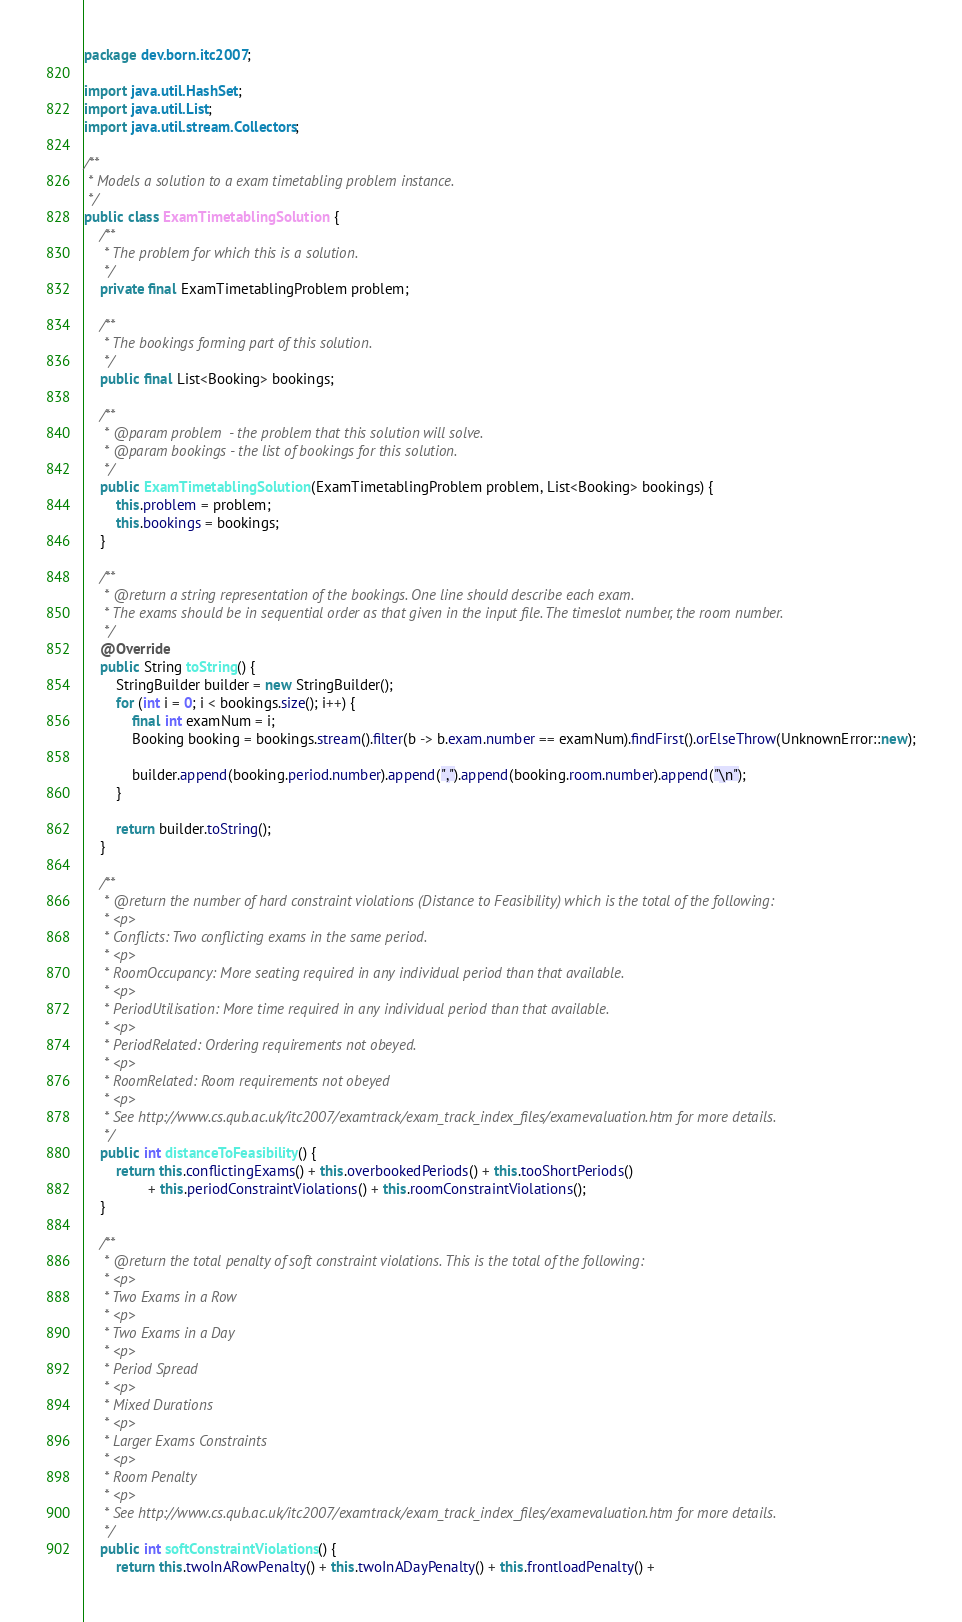<code> <loc_0><loc_0><loc_500><loc_500><_Java_>package dev.born.itc2007;

import java.util.HashSet;
import java.util.List;
import java.util.stream.Collectors;

/**
 * Models a solution to a exam timetabling problem instance.
 */
public class ExamTimetablingSolution {
	/**
	 * The problem for which this is a solution.
	 */
	private final ExamTimetablingProblem problem;

	/**
	 * The bookings forming part of this solution.
	 */
	public final List<Booking> bookings;

	/**
	 * @param problem  - the problem that this solution will solve.
	 * @param bookings - the list of bookings for this solution.
	 */
	public ExamTimetablingSolution(ExamTimetablingProblem problem, List<Booking> bookings) {
		this.problem = problem;
		this.bookings = bookings;
	}

	/**
	 * @return a string representation of the bookings. One line should describe each exam.
	 * The exams should be in sequential order as that given in the input file. The timeslot number, the room number.
	 */
	@Override
	public String toString() {
		StringBuilder builder = new StringBuilder();
		for (int i = 0; i < bookings.size(); i++) {
			final int examNum = i;
			Booking booking = bookings.stream().filter(b -> b.exam.number == examNum).findFirst().orElseThrow(UnknownError::new);

			builder.append(booking.period.number).append(",").append(booking.room.number).append("\n");
		}

		return builder.toString();
	}

	/**
	 * @return the number of hard constraint violations (Distance to Feasibility) which is the total of the following:
	 * <p>
	 * Conflicts: Two conflicting exams in the same period.
	 * <p>
	 * RoomOccupancy: More seating required in any individual period than that available.
	 * <p>
	 * PeriodUtilisation: More time required in any individual period than that available.
	 * <p>
	 * PeriodRelated: Ordering requirements not obeyed.
	 * <p>
	 * RoomRelated: Room requirements not obeyed
	 * <p>
	 * See http://www.cs.qub.ac.uk/itc2007/examtrack/exam_track_index_files/examevaluation.htm for more details.
	 */
	public int distanceToFeasibility() {
		return this.conflictingExams() + this.overbookedPeriods() + this.tooShortPeriods()
				+ this.periodConstraintViolations() + this.roomConstraintViolations();
	}

	/**
	 * @return the total penalty of soft constraint violations. This is the total of the following:
	 * <p>
	 * Two Exams in a Row
	 * <p>
	 * Two Exams in a Day
	 * <p>
	 * Period Spread
	 * <p>
	 * Mixed Durations
	 * <p>
	 * Larger Exams Constraints
	 * <p>
	 * Room Penalty
	 * <p>
	 * See http://www.cs.qub.ac.uk/itc2007/examtrack/exam_track_index_files/examevaluation.htm for more details.
	 */
	public int softConstraintViolations() {
		return this.twoInARowPenalty() + this.twoInADayPenalty() + this.frontloadPenalty() +</code> 